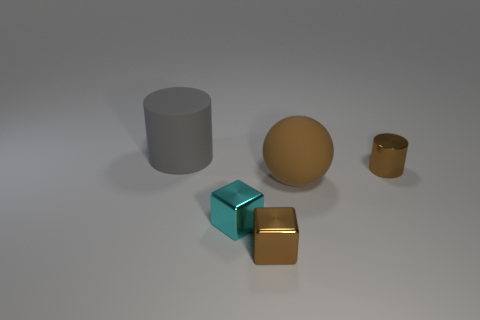Add 4 tiny red matte objects. How many objects exist? 9 Add 3 brown cubes. How many brown cubes exist? 4 Subtract 0 purple spheres. How many objects are left? 5 Subtract all balls. How many objects are left? 4 Subtract all tiny blue cubes. Subtract all metal cubes. How many objects are left? 3 Add 3 gray matte cylinders. How many gray matte cylinders are left? 4 